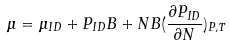<formula> <loc_0><loc_0><loc_500><loc_500>\mu = \mu _ { I D } + P _ { I D } B + N B ( \frac { \partial P _ { I D } } { \partial N } ) _ { P , T }</formula> 